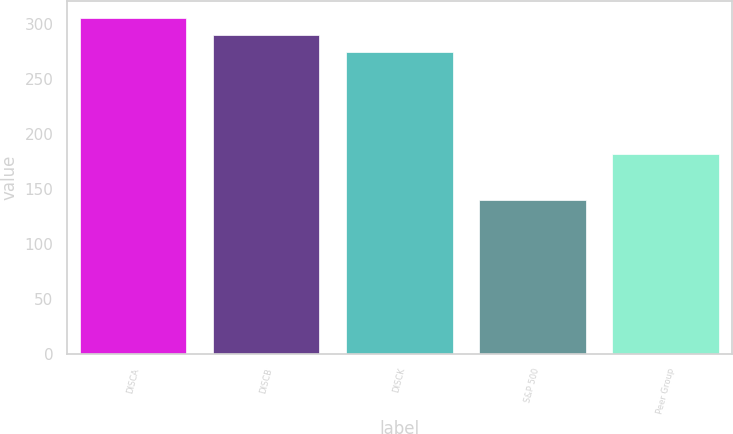<chart> <loc_0><loc_0><loc_500><loc_500><bar_chart><fcel>DISCA<fcel>DISCB<fcel>DISCK<fcel>S&P 500<fcel>Peer Group<nl><fcel>305.07<fcel>289.54<fcel>274.01<fcel>139.23<fcel>181<nl></chart> 